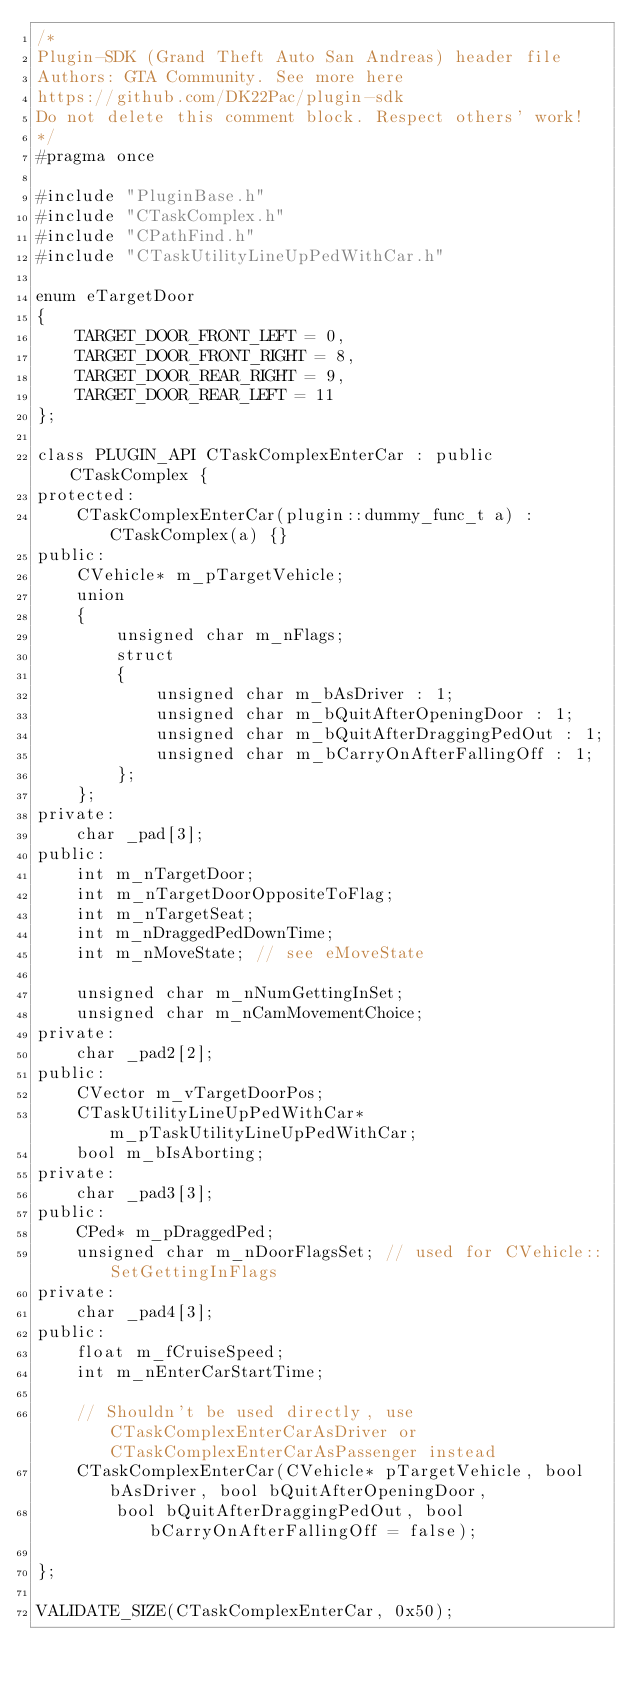<code> <loc_0><loc_0><loc_500><loc_500><_C_>/*
Plugin-SDK (Grand Theft Auto San Andreas) header file
Authors: GTA Community. See more here
https://github.com/DK22Pac/plugin-sdk
Do not delete this comment block. Respect others' work!
*/
#pragma once

#include "PluginBase.h"
#include "CTaskComplex.h"
#include "CPathFind.h"
#include "CTaskUtilityLineUpPedWithCar.h"

enum eTargetDoor
{
    TARGET_DOOR_FRONT_LEFT = 0,
    TARGET_DOOR_FRONT_RIGHT = 8,
    TARGET_DOOR_REAR_RIGHT = 9,
    TARGET_DOOR_REAR_LEFT = 11
};

class PLUGIN_API CTaskComplexEnterCar : public CTaskComplex {
protected:
    CTaskComplexEnterCar(plugin::dummy_func_t a) : CTaskComplex(a) {}
public:
    CVehicle* m_pTargetVehicle;
    union
    {
        unsigned char m_nFlags;
        struct
        {
            unsigned char m_bAsDriver : 1;
            unsigned char m_bQuitAfterOpeningDoor : 1;
            unsigned char m_bQuitAfterDraggingPedOut : 1;
            unsigned char m_bCarryOnAfterFallingOff : 1;
        };
    };
private:
    char _pad[3];
public:
    int m_nTargetDoor;
    int m_nTargetDoorOppositeToFlag;
    int m_nTargetSeat;
    int m_nDraggedPedDownTime;
    int m_nMoveState; // see eMoveState

    unsigned char m_nNumGettingInSet;
    unsigned char m_nCamMovementChoice;
private:
    char _pad2[2];
public:
    CVector m_vTargetDoorPos;
    CTaskUtilityLineUpPedWithCar* m_pTaskUtilityLineUpPedWithCar;
    bool m_bIsAborting;
private:
    char _pad3[3];
public:
    CPed* m_pDraggedPed;
    unsigned char m_nDoorFlagsSet; // used for CVehicle::SetGettingInFlags
private:
    char _pad4[3];
public:
    float m_fCruiseSpeed;
    int m_nEnterCarStartTime;

    // Shouldn't be used directly, use CTaskComplexEnterCarAsDriver or CTaskComplexEnterCarAsPassenger instead
    CTaskComplexEnterCar(CVehicle* pTargetVehicle, bool bAsDriver, bool bQuitAfterOpeningDoor,
        bool bQuitAfterDraggingPedOut, bool bCarryOnAfterFallingOff = false); 

};

VALIDATE_SIZE(CTaskComplexEnterCar, 0x50);
</code> 